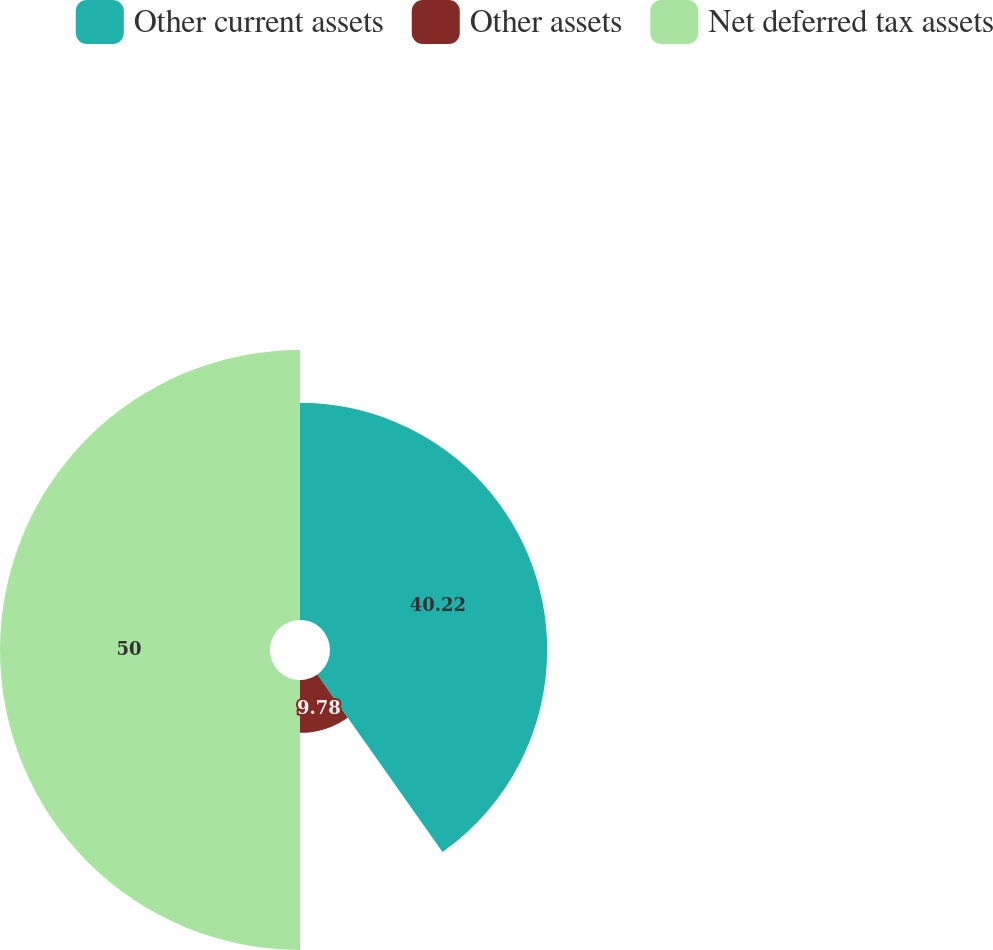Convert chart to OTSL. <chart><loc_0><loc_0><loc_500><loc_500><pie_chart><fcel>Other current assets<fcel>Other assets<fcel>Net deferred tax assets<nl><fcel>40.22%<fcel>9.78%<fcel>50.0%<nl></chart> 